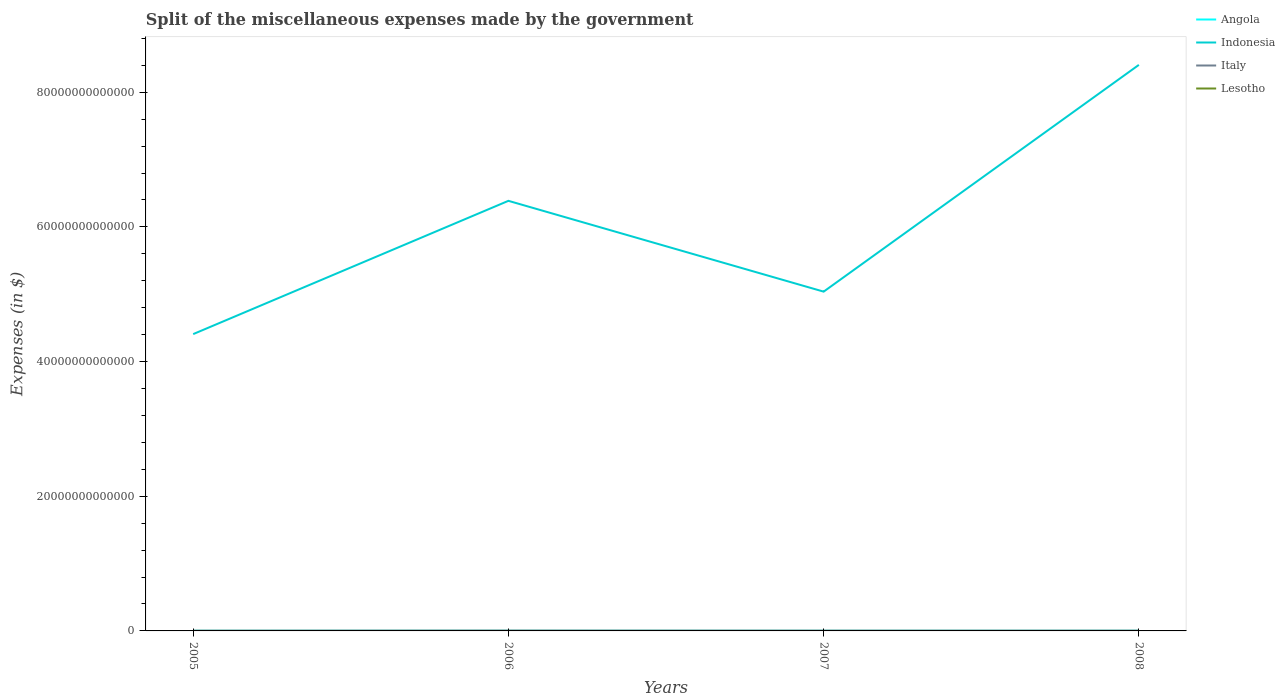Does the line corresponding to Indonesia intersect with the line corresponding to Lesotho?
Give a very brief answer. No. Across all years, what is the maximum miscellaneous expenses made by the government in Angola?
Keep it short and to the point. 2.17e+1. In which year was the miscellaneous expenses made by the government in Lesotho maximum?
Your answer should be very brief. 2005. What is the total miscellaneous expenses made by the government in Angola in the graph?
Provide a short and direct response. -2.01e+09. What is the difference between the highest and the second highest miscellaneous expenses made by the government in Indonesia?
Make the answer very short. 4.00e+13. Is the miscellaneous expenses made by the government in Italy strictly greater than the miscellaneous expenses made by the government in Indonesia over the years?
Ensure brevity in your answer.  Yes. How many lines are there?
Ensure brevity in your answer.  4. What is the difference between two consecutive major ticks on the Y-axis?
Give a very brief answer. 2.00e+13. How many legend labels are there?
Keep it short and to the point. 4. What is the title of the graph?
Ensure brevity in your answer.  Split of the miscellaneous expenses made by the government. Does "Sudan" appear as one of the legend labels in the graph?
Offer a terse response. No. What is the label or title of the Y-axis?
Your answer should be compact. Expenses (in $). What is the Expenses (in $) of Angola in 2005?
Your answer should be compact. 2.17e+1. What is the Expenses (in $) of Indonesia in 2005?
Keep it short and to the point. 4.41e+13. What is the Expenses (in $) in Italy in 2005?
Offer a terse response. 3.03e+1. What is the Expenses (in $) in Lesotho in 2005?
Ensure brevity in your answer.  3662.6. What is the Expenses (in $) in Angola in 2006?
Your response must be concise. 2.22e+1. What is the Expenses (in $) of Indonesia in 2006?
Offer a very short reply. 6.39e+13. What is the Expenses (in $) of Italy in 2006?
Give a very brief answer. 4.68e+1. What is the Expenses (in $) in Lesotho in 2006?
Keep it short and to the point. 2.85e+08. What is the Expenses (in $) in Angola in 2007?
Provide a succinct answer. 2.19e+1. What is the Expenses (in $) of Indonesia in 2007?
Keep it short and to the point. 5.04e+13. What is the Expenses (in $) in Italy in 2007?
Provide a succinct answer. 3.51e+1. What is the Expenses (in $) in Lesotho in 2007?
Make the answer very short. 4.42e+08. What is the Expenses (in $) in Angola in 2008?
Keep it short and to the point. 2.38e+1. What is the Expenses (in $) of Indonesia in 2008?
Offer a very short reply. 8.41e+13. What is the Expenses (in $) of Italy in 2008?
Your answer should be very brief. 3.38e+1. What is the Expenses (in $) in Lesotho in 2008?
Your response must be concise. 4.46e+08. Across all years, what is the maximum Expenses (in $) of Angola?
Give a very brief answer. 2.38e+1. Across all years, what is the maximum Expenses (in $) in Indonesia?
Keep it short and to the point. 8.41e+13. Across all years, what is the maximum Expenses (in $) of Italy?
Keep it short and to the point. 4.68e+1. Across all years, what is the maximum Expenses (in $) of Lesotho?
Your response must be concise. 4.46e+08. Across all years, what is the minimum Expenses (in $) of Angola?
Ensure brevity in your answer.  2.17e+1. Across all years, what is the minimum Expenses (in $) in Indonesia?
Make the answer very short. 4.41e+13. Across all years, what is the minimum Expenses (in $) in Italy?
Provide a short and direct response. 3.03e+1. Across all years, what is the minimum Expenses (in $) in Lesotho?
Give a very brief answer. 3662.6. What is the total Expenses (in $) in Angola in the graph?
Keep it short and to the point. 8.96e+1. What is the total Expenses (in $) of Indonesia in the graph?
Keep it short and to the point. 2.42e+14. What is the total Expenses (in $) in Italy in the graph?
Keep it short and to the point. 1.46e+11. What is the total Expenses (in $) in Lesotho in the graph?
Your answer should be very brief. 1.17e+09. What is the difference between the Expenses (in $) in Angola in 2005 and that in 2006?
Your answer should be very brief. -4.93e+08. What is the difference between the Expenses (in $) in Indonesia in 2005 and that in 2006?
Offer a very short reply. -1.98e+13. What is the difference between the Expenses (in $) in Italy in 2005 and that in 2006?
Offer a terse response. -1.66e+1. What is the difference between the Expenses (in $) of Lesotho in 2005 and that in 2006?
Make the answer very short. -2.85e+08. What is the difference between the Expenses (in $) of Angola in 2005 and that in 2007?
Give a very brief answer. -1.26e+08. What is the difference between the Expenses (in $) in Indonesia in 2005 and that in 2007?
Provide a short and direct response. -6.31e+12. What is the difference between the Expenses (in $) in Italy in 2005 and that in 2007?
Your response must be concise. -4.82e+09. What is the difference between the Expenses (in $) of Lesotho in 2005 and that in 2007?
Provide a succinct answer. -4.42e+08. What is the difference between the Expenses (in $) in Angola in 2005 and that in 2008?
Your answer should be compact. -2.01e+09. What is the difference between the Expenses (in $) of Indonesia in 2005 and that in 2008?
Ensure brevity in your answer.  -4.00e+13. What is the difference between the Expenses (in $) in Italy in 2005 and that in 2008?
Provide a succinct answer. -3.49e+09. What is the difference between the Expenses (in $) in Lesotho in 2005 and that in 2008?
Your answer should be compact. -4.46e+08. What is the difference between the Expenses (in $) in Angola in 2006 and that in 2007?
Your response must be concise. 3.67e+08. What is the difference between the Expenses (in $) of Indonesia in 2006 and that in 2007?
Provide a short and direct response. 1.35e+13. What is the difference between the Expenses (in $) in Italy in 2006 and that in 2007?
Your response must be concise. 1.17e+1. What is the difference between the Expenses (in $) of Lesotho in 2006 and that in 2007?
Give a very brief answer. -1.56e+08. What is the difference between the Expenses (in $) in Angola in 2006 and that in 2008?
Your response must be concise. -1.52e+09. What is the difference between the Expenses (in $) in Indonesia in 2006 and that in 2008?
Keep it short and to the point. -2.02e+13. What is the difference between the Expenses (in $) of Italy in 2006 and that in 2008?
Offer a terse response. 1.31e+1. What is the difference between the Expenses (in $) of Lesotho in 2006 and that in 2008?
Offer a very short reply. -1.60e+08. What is the difference between the Expenses (in $) of Angola in 2007 and that in 2008?
Your response must be concise. -1.88e+09. What is the difference between the Expenses (in $) of Indonesia in 2007 and that in 2008?
Ensure brevity in your answer.  -3.37e+13. What is the difference between the Expenses (in $) in Italy in 2007 and that in 2008?
Your answer should be compact. 1.33e+09. What is the difference between the Expenses (in $) in Lesotho in 2007 and that in 2008?
Ensure brevity in your answer.  -4.11e+06. What is the difference between the Expenses (in $) of Angola in 2005 and the Expenses (in $) of Indonesia in 2006?
Keep it short and to the point. -6.39e+13. What is the difference between the Expenses (in $) of Angola in 2005 and the Expenses (in $) of Italy in 2006?
Your answer should be very brief. -2.51e+1. What is the difference between the Expenses (in $) in Angola in 2005 and the Expenses (in $) in Lesotho in 2006?
Give a very brief answer. 2.15e+1. What is the difference between the Expenses (in $) in Indonesia in 2005 and the Expenses (in $) in Italy in 2006?
Provide a short and direct response. 4.40e+13. What is the difference between the Expenses (in $) in Indonesia in 2005 and the Expenses (in $) in Lesotho in 2006?
Your response must be concise. 4.41e+13. What is the difference between the Expenses (in $) of Italy in 2005 and the Expenses (in $) of Lesotho in 2006?
Your response must be concise. 3.00e+1. What is the difference between the Expenses (in $) of Angola in 2005 and the Expenses (in $) of Indonesia in 2007?
Provide a succinct answer. -5.04e+13. What is the difference between the Expenses (in $) of Angola in 2005 and the Expenses (in $) of Italy in 2007?
Your answer should be very brief. -1.34e+1. What is the difference between the Expenses (in $) in Angola in 2005 and the Expenses (in $) in Lesotho in 2007?
Your answer should be compact. 2.13e+1. What is the difference between the Expenses (in $) of Indonesia in 2005 and the Expenses (in $) of Italy in 2007?
Make the answer very short. 4.40e+13. What is the difference between the Expenses (in $) in Indonesia in 2005 and the Expenses (in $) in Lesotho in 2007?
Provide a succinct answer. 4.41e+13. What is the difference between the Expenses (in $) in Italy in 2005 and the Expenses (in $) in Lesotho in 2007?
Your response must be concise. 2.98e+1. What is the difference between the Expenses (in $) in Angola in 2005 and the Expenses (in $) in Indonesia in 2008?
Offer a terse response. -8.40e+13. What is the difference between the Expenses (in $) of Angola in 2005 and the Expenses (in $) of Italy in 2008?
Your answer should be very brief. -1.20e+1. What is the difference between the Expenses (in $) in Angola in 2005 and the Expenses (in $) in Lesotho in 2008?
Keep it short and to the point. 2.13e+1. What is the difference between the Expenses (in $) of Indonesia in 2005 and the Expenses (in $) of Italy in 2008?
Give a very brief answer. 4.40e+13. What is the difference between the Expenses (in $) of Indonesia in 2005 and the Expenses (in $) of Lesotho in 2008?
Make the answer very short. 4.41e+13. What is the difference between the Expenses (in $) of Italy in 2005 and the Expenses (in $) of Lesotho in 2008?
Your response must be concise. 2.98e+1. What is the difference between the Expenses (in $) in Angola in 2006 and the Expenses (in $) in Indonesia in 2007?
Offer a terse response. -5.04e+13. What is the difference between the Expenses (in $) of Angola in 2006 and the Expenses (in $) of Italy in 2007?
Offer a very short reply. -1.29e+1. What is the difference between the Expenses (in $) of Angola in 2006 and the Expenses (in $) of Lesotho in 2007?
Offer a very short reply. 2.18e+1. What is the difference between the Expenses (in $) of Indonesia in 2006 and the Expenses (in $) of Italy in 2007?
Give a very brief answer. 6.38e+13. What is the difference between the Expenses (in $) of Indonesia in 2006 and the Expenses (in $) of Lesotho in 2007?
Make the answer very short. 6.39e+13. What is the difference between the Expenses (in $) in Italy in 2006 and the Expenses (in $) in Lesotho in 2007?
Ensure brevity in your answer.  4.64e+1. What is the difference between the Expenses (in $) in Angola in 2006 and the Expenses (in $) in Indonesia in 2008?
Your response must be concise. -8.40e+13. What is the difference between the Expenses (in $) in Angola in 2006 and the Expenses (in $) in Italy in 2008?
Offer a very short reply. -1.15e+1. What is the difference between the Expenses (in $) in Angola in 2006 and the Expenses (in $) in Lesotho in 2008?
Offer a very short reply. 2.18e+1. What is the difference between the Expenses (in $) in Indonesia in 2006 and the Expenses (in $) in Italy in 2008?
Provide a short and direct response. 6.38e+13. What is the difference between the Expenses (in $) in Indonesia in 2006 and the Expenses (in $) in Lesotho in 2008?
Offer a very short reply. 6.39e+13. What is the difference between the Expenses (in $) in Italy in 2006 and the Expenses (in $) in Lesotho in 2008?
Provide a short and direct response. 4.64e+1. What is the difference between the Expenses (in $) of Angola in 2007 and the Expenses (in $) of Indonesia in 2008?
Your response must be concise. -8.40e+13. What is the difference between the Expenses (in $) of Angola in 2007 and the Expenses (in $) of Italy in 2008?
Your answer should be compact. -1.19e+1. What is the difference between the Expenses (in $) of Angola in 2007 and the Expenses (in $) of Lesotho in 2008?
Provide a short and direct response. 2.14e+1. What is the difference between the Expenses (in $) of Indonesia in 2007 and the Expenses (in $) of Italy in 2008?
Your response must be concise. 5.04e+13. What is the difference between the Expenses (in $) of Indonesia in 2007 and the Expenses (in $) of Lesotho in 2008?
Your answer should be compact. 5.04e+13. What is the difference between the Expenses (in $) in Italy in 2007 and the Expenses (in $) in Lesotho in 2008?
Your response must be concise. 3.47e+1. What is the average Expenses (in $) of Angola per year?
Your answer should be very brief. 2.24e+1. What is the average Expenses (in $) in Indonesia per year?
Your answer should be very brief. 6.06e+13. What is the average Expenses (in $) in Italy per year?
Provide a succinct answer. 3.65e+1. What is the average Expenses (in $) in Lesotho per year?
Make the answer very short. 2.93e+08. In the year 2005, what is the difference between the Expenses (in $) in Angola and Expenses (in $) in Indonesia?
Offer a very short reply. -4.41e+13. In the year 2005, what is the difference between the Expenses (in $) of Angola and Expenses (in $) of Italy?
Provide a short and direct response. -8.53e+09. In the year 2005, what is the difference between the Expenses (in $) of Angola and Expenses (in $) of Lesotho?
Provide a succinct answer. 2.17e+1. In the year 2005, what is the difference between the Expenses (in $) in Indonesia and Expenses (in $) in Italy?
Provide a short and direct response. 4.41e+13. In the year 2005, what is the difference between the Expenses (in $) in Indonesia and Expenses (in $) in Lesotho?
Ensure brevity in your answer.  4.41e+13. In the year 2005, what is the difference between the Expenses (in $) of Italy and Expenses (in $) of Lesotho?
Make the answer very short. 3.03e+1. In the year 2006, what is the difference between the Expenses (in $) in Angola and Expenses (in $) in Indonesia?
Your answer should be very brief. -6.39e+13. In the year 2006, what is the difference between the Expenses (in $) in Angola and Expenses (in $) in Italy?
Offer a very short reply. -2.46e+1. In the year 2006, what is the difference between the Expenses (in $) in Angola and Expenses (in $) in Lesotho?
Your response must be concise. 2.20e+1. In the year 2006, what is the difference between the Expenses (in $) in Indonesia and Expenses (in $) in Italy?
Your response must be concise. 6.38e+13. In the year 2006, what is the difference between the Expenses (in $) of Indonesia and Expenses (in $) of Lesotho?
Give a very brief answer. 6.39e+13. In the year 2006, what is the difference between the Expenses (in $) of Italy and Expenses (in $) of Lesotho?
Make the answer very short. 4.65e+1. In the year 2007, what is the difference between the Expenses (in $) of Angola and Expenses (in $) of Indonesia?
Your answer should be very brief. -5.04e+13. In the year 2007, what is the difference between the Expenses (in $) of Angola and Expenses (in $) of Italy?
Make the answer very short. -1.32e+1. In the year 2007, what is the difference between the Expenses (in $) of Angola and Expenses (in $) of Lesotho?
Provide a short and direct response. 2.14e+1. In the year 2007, what is the difference between the Expenses (in $) in Indonesia and Expenses (in $) in Italy?
Offer a very short reply. 5.04e+13. In the year 2007, what is the difference between the Expenses (in $) in Indonesia and Expenses (in $) in Lesotho?
Your response must be concise. 5.04e+13. In the year 2007, what is the difference between the Expenses (in $) in Italy and Expenses (in $) in Lesotho?
Provide a succinct answer. 3.47e+1. In the year 2008, what is the difference between the Expenses (in $) of Angola and Expenses (in $) of Indonesia?
Your response must be concise. -8.40e+13. In the year 2008, what is the difference between the Expenses (in $) in Angola and Expenses (in $) in Italy?
Your answer should be compact. -1.00e+1. In the year 2008, what is the difference between the Expenses (in $) in Angola and Expenses (in $) in Lesotho?
Your response must be concise. 2.33e+1. In the year 2008, what is the difference between the Expenses (in $) in Indonesia and Expenses (in $) in Italy?
Your answer should be compact. 8.40e+13. In the year 2008, what is the difference between the Expenses (in $) of Indonesia and Expenses (in $) of Lesotho?
Keep it short and to the point. 8.41e+13. In the year 2008, what is the difference between the Expenses (in $) in Italy and Expenses (in $) in Lesotho?
Offer a very short reply. 3.33e+1. What is the ratio of the Expenses (in $) in Angola in 2005 to that in 2006?
Your answer should be compact. 0.98. What is the ratio of the Expenses (in $) in Indonesia in 2005 to that in 2006?
Keep it short and to the point. 0.69. What is the ratio of the Expenses (in $) of Italy in 2005 to that in 2006?
Give a very brief answer. 0.65. What is the ratio of the Expenses (in $) of Indonesia in 2005 to that in 2007?
Offer a very short reply. 0.87. What is the ratio of the Expenses (in $) of Italy in 2005 to that in 2007?
Provide a succinct answer. 0.86. What is the ratio of the Expenses (in $) in Lesotho in 2005 to that in 2007?
Keep it short and to the point. 0. What is the ratio of the Expenses (in $) in Angola in 2005 to that in 2008?
Ensure brevity in your answer.  0.92. What is the ratio of the Expenses (in $) of Indonesia in 2005 to that in 2008?
Your answer should be very brief. 0.52. What is the ratio of the Expenses (in $) in Italy in 2005 to that in 2008?
Offer a very short reply. 0.9. What is the ratio of the Expenses (in $) of Lesotho in 2005 to that in 2008?
Provide a succinct answer. 0. What is the ratio of the Expenses (in $) in Angola in 2006 to that in 2007?
Your answer should be very brief. 1.02. What is the ratio of the Expenses (in $) of Indonesia in 2006 to that in 2007?
Keep it short and to the point. 1.27. What is the ratio of the Expenses (in $) in Italy in 2006 to that in 2007?
Your answer should be very brief. 1.33. What is the ratio of the Expenses (in $) in Lesotho in 2006 to that in 2007?
Offer a terse response. 0.65. What is the ratio of the Expenses (in $) of Angola in 2006 to that in 2008?
Keep it short and to the point. 0.94. What is the ratio of the Expenses (in $) of Indonesia in 2006 to that in 2008?
Keep it short and to the point. 0.76. What is the ratio of the Expenses (in $) of Italy in 2006 to that in 2008?
Keep it short and to the point. 1.39. What is the ratio of the Expenses (in $) in Lesotho in 2006 to that in 2008?
Offer a terse response. 0.64. What is the ratio of the Expenses (in $) in Angola in 2007 to that in 2008?
Make the answer very short. 0.92. What is the ratio of the Expenses (in $) of Indonesia in 2007 to that in 2008?
Your answer should be very brief. 0.6. What is the ratio of the Expenses (in $) in Italy in 2007 to that in 2008?
Your answer should be very brief. 1.04. What is the difference between the highest and the second highest Expenses (in $) of Angola?
Give a very brief answer. 1.52e+09. What is the difference between the highest and the second highest Expenses (in $) of Indonesia?
Ensure brevity in your answer.  2.02e+13. What is the difference between the highest and the second highest Expenses (in $) in Italy?
Keep it short and to the point. 1.17e+1. What is the difference between the highest and the second highest Expenses (in $) in Lesotho?
Your answer should be compact. 4.11e+06. What is the difference between the highest and the lowest Expenses (in $) in Angola?
Offer a very short reply. 2.01e+09. What is the difference between the highest and the lowest Expenses (in $) in Indonesia?
Your response must be concise. 4.00e+13. What is the difference between the highest and the lowest Expenses (in $) in Italy?
Your answer should be very brief. 1.66e+1. What is the difference between the highest and the lowest Expenses (in $) in Lesotho?
Give a very brief answer. 4.46e+08. 